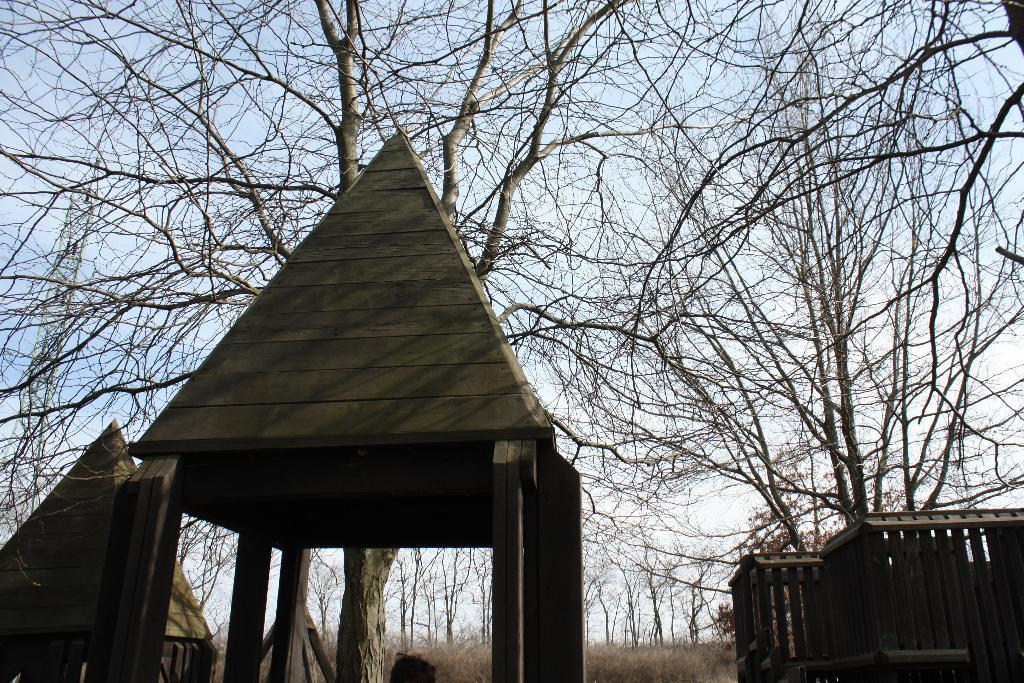What type of structures are visible in the image? There are tent houses in the image. What type of vegetation can be seen in the image? There are trees in the image. What is visible in the sky in the image? The sky is visible in the image. What type of ground cover is present in the image? Grass is present in the image. What type of cart is being used by the spy in the image? There is no cart or spy present in the image. What is the reason for the tent houses being set up in the image? The provided facts do not give any information about the reason for the tent houses being set up in the image. 